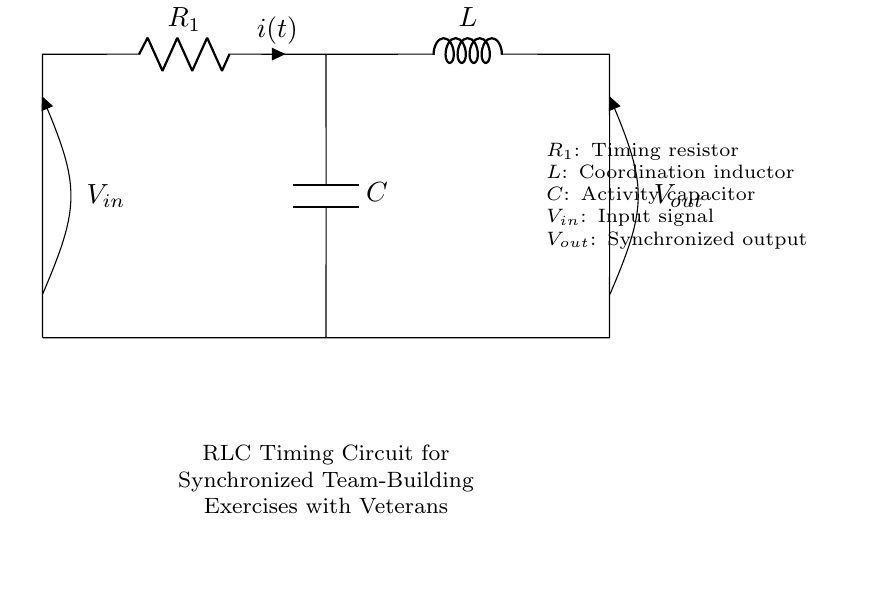What is the function of R1 in this circuit? R1 acts as the timing resistor, which is critical in controlling the timing characteristics of the RLC circuit.
Answer: Timing resistor What is the role of the inductor in an RLC circuit? The inductor, indicated as L, helps in coordinating the timing of the output signal by storing energy in a magnetic field and releasing it at a later time, thus affecting the circuit's resonance.
Answer: Coordination What does C represent in this diagram? C represents the activity capacitor, which stores energy in an electric field and affects the timing of the circuit's response to input signals.
Answer: Activity capacitor What are the input and output voltages labeled as? The input voltage is labeled V_in at the left side of the diagram, and the output voltage is labeled V_out at the right side of the circuit.
Answer: V_in and V_out How does the interaction of R, L, and C affect timing? The interaction of the resistor, inductor, and capacitor determines the time constants of the circuit, influencing how quickly the circuit responds to changes in input signal and synchronizing team-building exercises effectively.
Answer: Affects timing What type of circuit is depicted in this diagram? The circuit depicted is a Resistor-Inductor-Capacitor (RLC) timing circuit, which is used for managing the timing and synchronization of activities.
Answer: RLC timing circuit What could be a real-world application of this RLC timing circuit? A real-world application could be to synchronize team-building exercises among veterans, ensuring that activities proceed in a coordinated manner according to the timing determined by the circuit.
Answer: Synchronized activities 